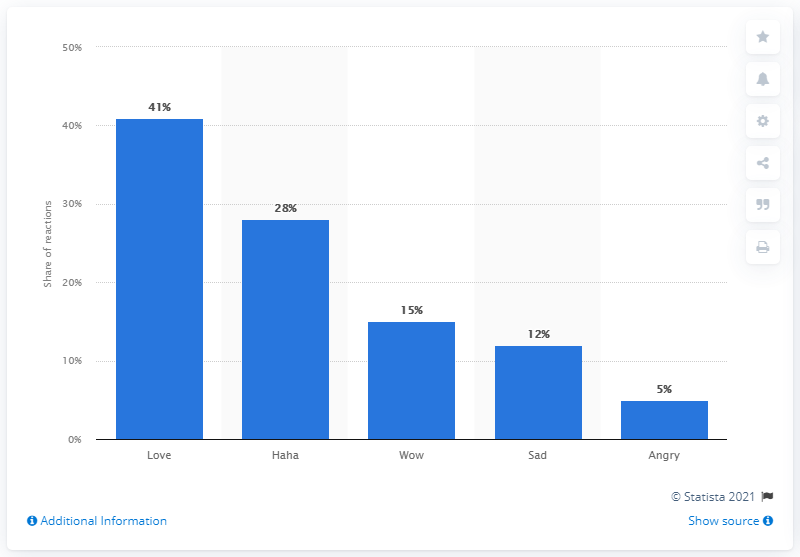Mention a couple of crucial points in this snapshot. The most popular Facebook reaction on the top shared posts in September 2017 was love. 